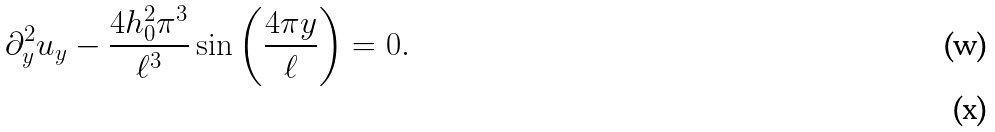<formula> <loc_0><loc_0><loc_500><loc_500>\partial _ { y } ^ { 2 } u _ { y } - \frac { 4 h _ { 0 } ^ { 2 } \pi ^ { 3 } } { \ell ^ { 3 } } \sin \left ( \frac { 4 \pi y } { \ell } \right ) = 0 . \\</formula> 